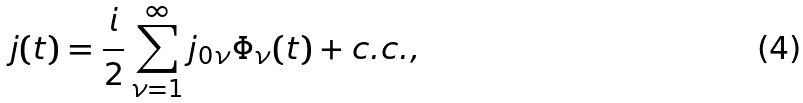Convert formula to latex. <formula><loc_0><loc_0><loc_500><loc_500>j ( t ) = { \frac { i } { 2 } } \sum _ { \nu = 1 } ^ { \infty } j _ { 0 \nu } \Phi _ { \nu } ( t ) + c . c . ,</formula> 